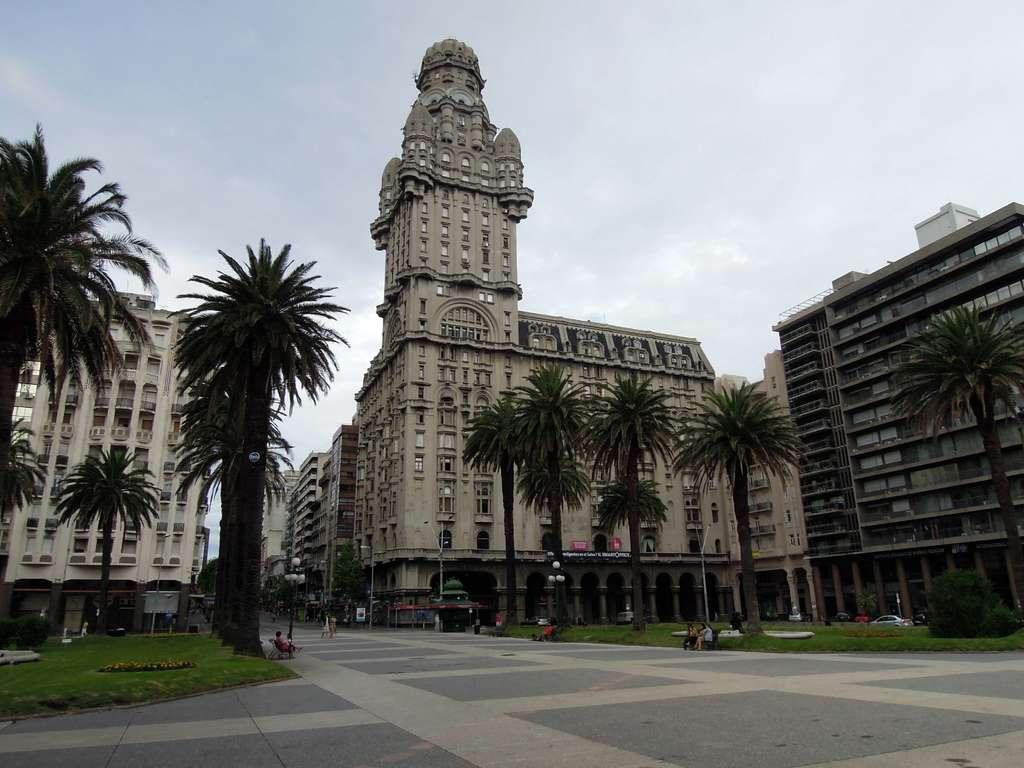Please provide a concise description of this image. In this image we can see walkway, through which some persons are walking and some are sitting on benches, we can see some grass, trees, vehicles and in the background of the image there are some buildings and clear sky. 